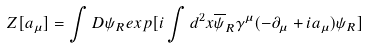<formula> <loc_0><loc_0><loc_500><loc_500>Z [ a _ { \mu } ] = \int D \psi _ { R } e x p [ i \int d ^ { 2 } x \overline { \psi } _ { R } \gamma ^ { \mu } ( - \partial _ { \mu } + i a _ { \mu } ) \psi _ { R } ]</formula> 